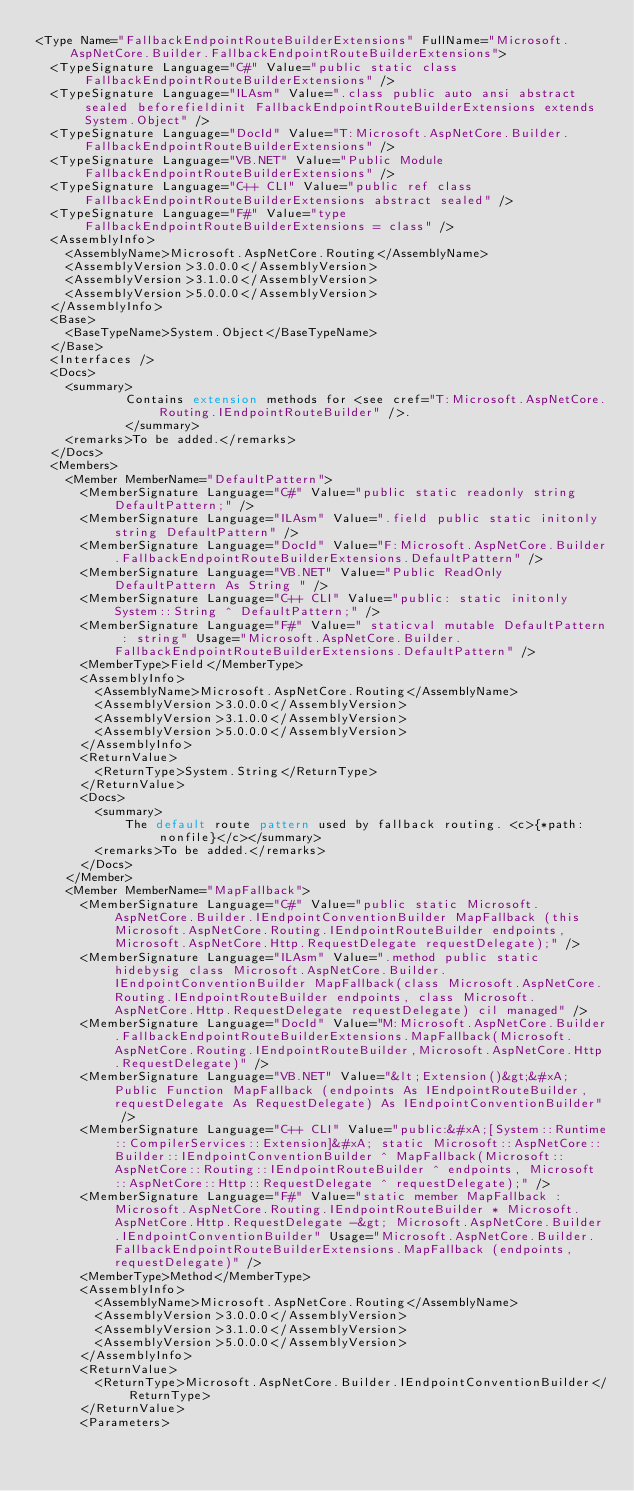Convert code to text. <code><loc_0><loc_0><loc_500><loc_500><_XML_><Type Name="FallbackEndpointRouteBuilderExtensions" FullName="Microsoft.AspNetCore.Builder.FallbackEndpointRouteBuilderExtensions">
  <TypeSignature Language="C#" Value="public static class FallbackEndpointRouteBuilderExtensions" />
  <TypeSignature Language="ILAsm" Value=".class public auto ansi abstract sealed beforefieldinit FallbackEndpointRouteBuilderExtensions extends System.Object" />
  <TypeSignature Language="DocId" Value="T:Microsoft.AspNetCore.Builder.FallbackEndpointRouteBuilderExtensions" />
  <TypeSignature Language="VB.NET" Value="Public Module FallbackEndpointRouteBuilderExtensions" />
  <TypeSignature Language="C++ CLI" Value="public ref class FallbackEndpointRouteBuilderExtensions abstract sealed" />
  <TypeSignature Language="F#" Value="type FallbackEndpointRouteBuilderExtensions = class" />
  <AssemblyInfo>
    <AssemblyName>Microsoft.AspNetCore.Routing</AssemblyName>
    <AssemblyVersion>3.0.0.0</AssemblyVersion>
    <AssemblyVersion>3.1.0.0</AssemblyVersion>
    <AssemblyVersion>5.0.0.0</AssemblyVersion>
  </AssemblyInfo>
  <Base>
    <BaseTypeName>System.Object</BaseTypeName>
  </Base>
  <Interfaces />
  <Docs>
    <summary>
            Contains extension methods for <see cref="T:Microsoft.AspNetCore.Routing.IEndpointRouteBuilder" />.
            </summary>
    <remarks>To be added.</remarks>
  </Docs>
  <Members>
    <Member MemberName="DefaultPattern">
      <MemberSignature Language="C#" Value="public static readonly string DefaultPattern;" />
      <MemberSignature Language="ILAsm" Value=".field public static initonly string DefaultPattern" />
      <MemberSignature Language="DocId" Value="F:Microsoft.AspNetCore.Builder.FallbackEndpointRouteBuilderExtensions.DefaultPattern" />
      <MemberSignature Language="VB.NET" Value="Public ReadOnly DefaultPattern As String " />
      <MemberSignature Language="C++ CLI" Value="public: static initonly System::String ^ DefaultPattern;" />
      <MemberSignature Language="F#" Value=" staticval mutable DefaultPattern : string" Usage="Microsoft.AspNetCore.Builder.FallbackEndpointRouteBuilderExtensions.DefaultPattern" />
      <MemberType>Field</MemberType>
      <AssemblyInfo>
        <AssemblyName>Microsoft.AspNetCore.Routing</AssemblyName>
        <AssemblyVersion>3.0.0.0</AssemblyVersion>
        <AssemblyVersion>3.1.0.0</AssemblyVersion>
        <AssemblyVersion>5.0.0.0</AssemblyVersion>
      </AssemblyInfo>
      <ReturnValue>
        <ReturnType>System.String</ReturnType>
      </ReturnValue>
      <Docs>
        <summary>
            The default route pattern used by fallback routing. <c>{*path:nonfile}</c></summary>
        <remarks>To be added.</remarks>
      </Docs>
    </Member>
    <Member MemberName="MapFallback">
      <MemberSignature Language="C#" Value="public static Microsoft.AspNetCore.Builder.IEndpointConventionBuilder MapFallback (this Microsoft.AspNetCore.Routing.IEndpointRouteBuilder endpoints, Microsoft.AspNetCore.Http.RequestDelegate requestDelegate);" />
      <MemberSignature Language="ILAsm" Value=".method public static hidebysig class Microsoft.AspNetCore.Builder.IEndpointConventionBuilder MapFallback(class Microsoft.AspNetCore.Routing.IEndpointRouteBuilder endpoints, class Microsoft.AspNetCore.Http.RequestDelegate requestDelegate) cil managed" />
      <MemberSignature Language="DocId" Value="M:Microsoft.AspNetCore.Builder.FallbackEndpointRouteBuilderExtensions.MapFallback(Microsoft.AspNetCore.Routing.IEndpointRouteBuilder,Microsoft.AspNetCore.Http.RequestDelegate)" />
      <MemberSignature Language="VB.NET" Value="&lt;Extension()&gt;&#xA;Public Function MapFallback (endpoints As IEndpointRouteBuilder, requestDelegate As RequestDelegate) As IEndpointConventionBuilder" />
      <MemberSignature Language="C++ CLI" Value="public:&#xA;[System::Runtime::CompilerServices::Extension]&#xA; static Microsoft::AspNetCore::Builder::IEndpointConventionBuilder ^ MapFallback(Microsoft::AspNetCore::Routing::IEndpointRouteBuilder ^ endpoints, Microsoft::AspNetCore::Http::RequestDelegate ^ requestDelegate);" />
      <MemberSignature Language="F#" Value="static member MapFallback : Microsoft.AspNetCore.Routing.IEndpointRouteBuilder * Microsoft.AspNetCore.Http.RequestDelegate -&gt; Microsoft.AspNetCore.Builder.IEndpointConventionBuilder" Usage="Microsoft.AspNetCore.Builder.FallbackEndpointRouteBuilderExtensions.MapFallback (endpoints, requestDelegate)" />
      <MemberType>Method</MemberType>
      <AssemblyInfo>
        <AssemblyName>Microsoft.AspNetCore.Routing</AssemblyName>
        <AssemblyVersion>3.0.0.0</AssemblyVersion>
        <AssemblyVersion>3.1.0.0</AssemblyVersion>
        <AssemblyVersion>5.0.0.0</AssemblyVersion>
      </AssemblyInfo>
      <ReturnValue>
        <ReturnType>Microsoft.AspNetCore.Builder.IEndpointConventionBuilder</ReturnType>
      </ReturnValue>
      <Parameters></code> 